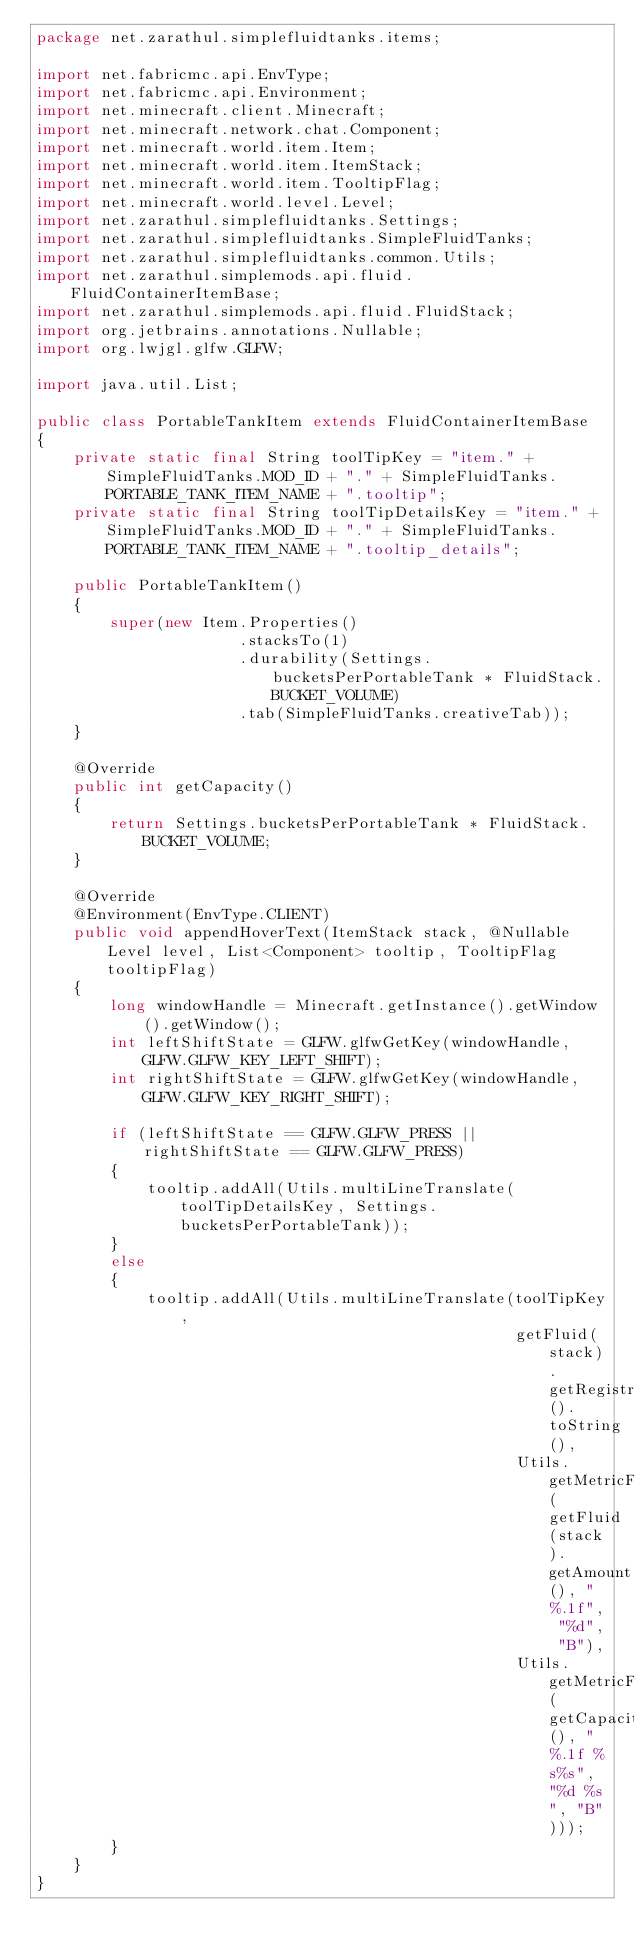<code> <loc_0><loc_0><loc_500><loc_500><_Java_>package net.zarathul.simplefluidtanks.items;

import net.fabricmc.api.EnvType;
import net.fabricmc.api.Environment;
import net.minecraft.client.Minecraft;
import net.minecraft.network.chat.Component;
import net.minecraft.world.item.Item;
import net.minecraft.world.item.ItemStack;
import net.minecraft.world.item.TooltipFlag;
import net.minecraft.world.level.Level;
import net.zarathul.simplefluidtanks.Settings;
import net.zarathul.simplefluidtanks.SimpleFluidTanks;
import net.zarathul.simplefluidtanks.common.Utils;
import net.zarathul.simplemods.api.fluid.FluidContainerItemBase;
import net.zarathul.simplemods.api.fluid.FluidStack;
import org.jetbrains.annotations.Nullable;
import org.lwjgl.glfw.GLFW;

import java.util.List;

public class PortableTankItem extends FluidContainerItemBase
{
	private static final String toolTipKey = "item." + SimpleFluidTanks.MOD_ID + "." + SimpleFluidTanks.PORTABLE_TANK_ITEM_NAME + ".tooltip";
	private static final String toolTipDetailsKey = "item." + SimpleFluidTanks.MOD_ID + "." + SimpleFluidTanks.PORTABLE_TANK_ITEM_NAME + ".tooltip_details";

	public PortableTankItem()
	{
		super(new Item.Properties()
					  .stacksTo(1)
					  .durability(Settings.bucketsPerPortableTank * FluidStack.BUCKET_VOLUME)
					  .tab(SimpleFluidTanks.creativeTab));
	}

	@Override
	public int getCapacity()
	{
		return Settings.bucketsPerPortableTank * FluidStack.BUCKET_VOLUME;
	}

	@Override
	@Environment(EnvType.CLIENT)
	public void appendHoverText(ItemStack stack, @Nullable Level level, List<Component> tooltip, TooltipFlag tooltipFlag)
	{
		long windowHandle = Minecraft.getInstance().getWindow().getWindow();
		int leftShiftState = GLFW.glfwGetKey(windowHandle, GLFW.GLFW_KEY_LEFT_SHIFT);
		int rightShiftState = GLFW.glfwGetKey(windowHandle, GLFW.GLFW_KEY_RIGHT_SHIFT);

		if (leftShiftState == GLFW.GLFW_PRESS || rightShiftState == GLFW.GLFW_PRESS)
		{
			tooltip.addAll(Utils.multiLineTranslate(toolTipDetailsKey, Settings.bucketsPerPortableTank));
		}
		else
		{
			tooltip.addAll(Utils.multiLineTranslate(toolTipKey,
													getFluid(stack).getRegistryKey().toString(),
													Utils.getMetricFormattedNumber(getFluid(stack).getAmount(), "%.1f", "%d", "B"),
													Utils.getMetricFormattedNumber(getCapacity(), "%.1f %s%s", "%d %s", "B")));
		}
	}
}
</code> 